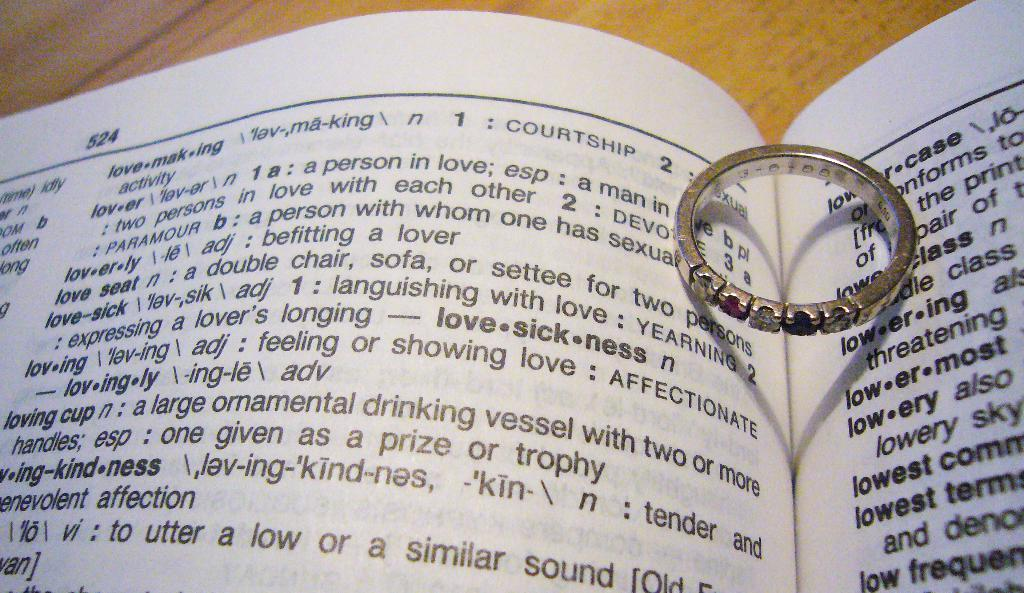<image>
Offer a succinct explanation of the picture presented. A dictionary opened up to page number 524 